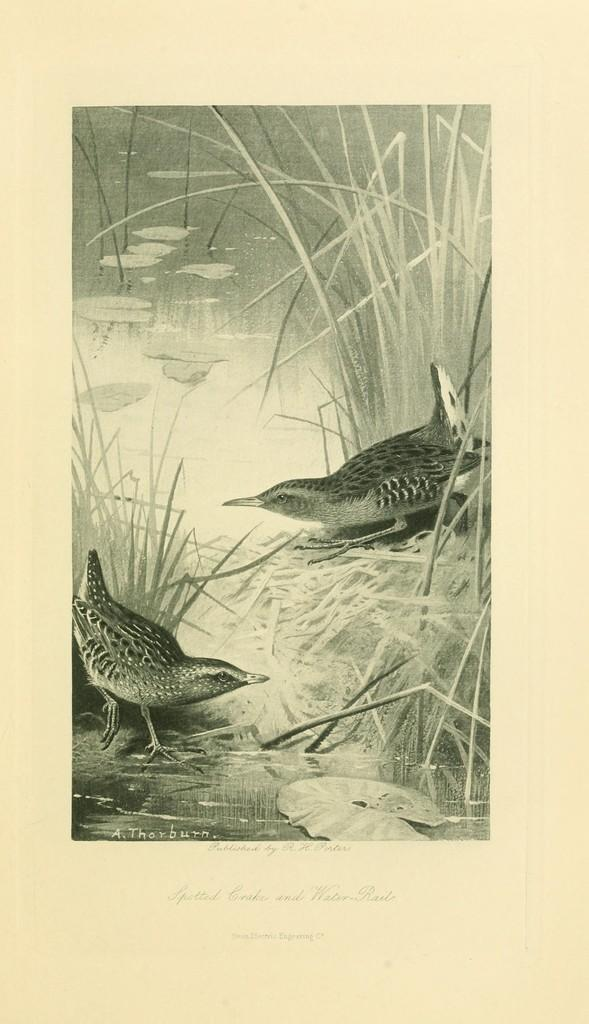What type of artwork is the image? The image is a painting. What type of animals can be seen in the painting? There are birds in the painting. What type of natural environment is depicted in the painting? There is grass, water, and plants depicted in the painting. What type of blood is visible on the birds in the painting? There is no blood visible on the birds in the painting; they are depicted in a natural setting. What type of brass instrument can be seen in the painting? There is no brass instrument present in the painting. 